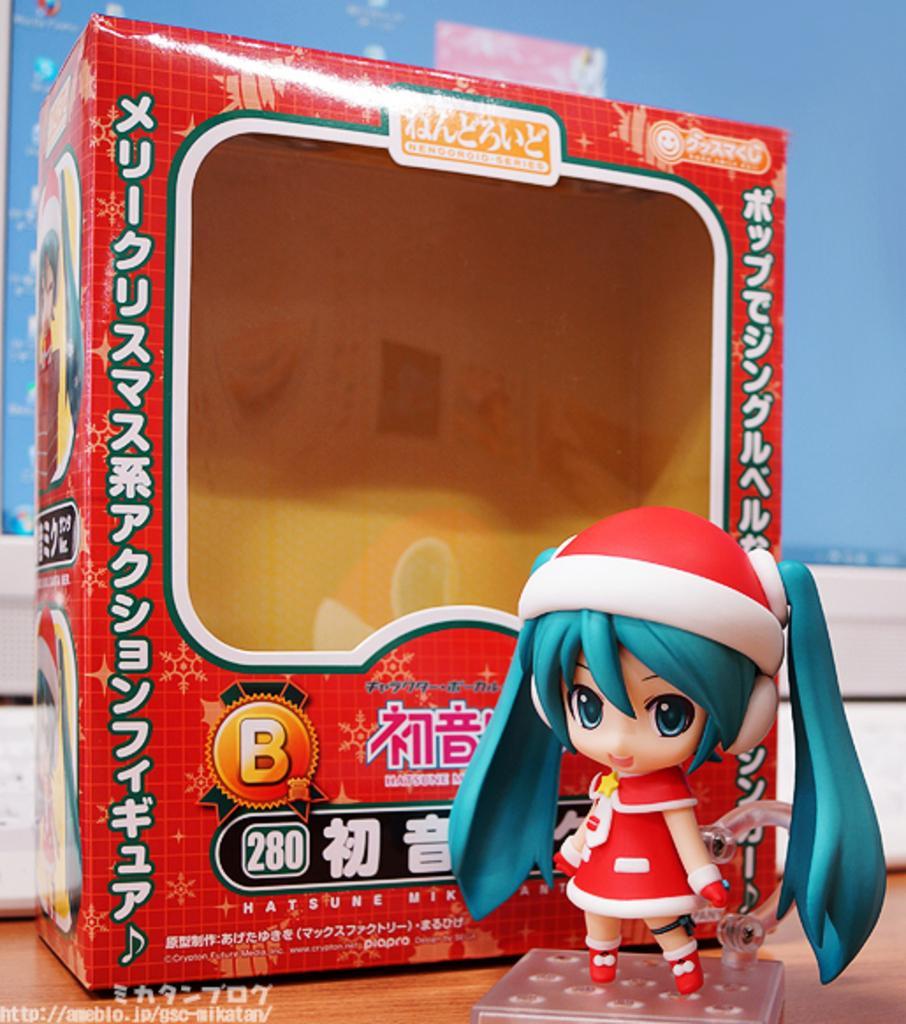How would you summarize this image in a sentence or two? In this picture we can see a doll and a box on the wooden surface. In the background we can see a monitor. 